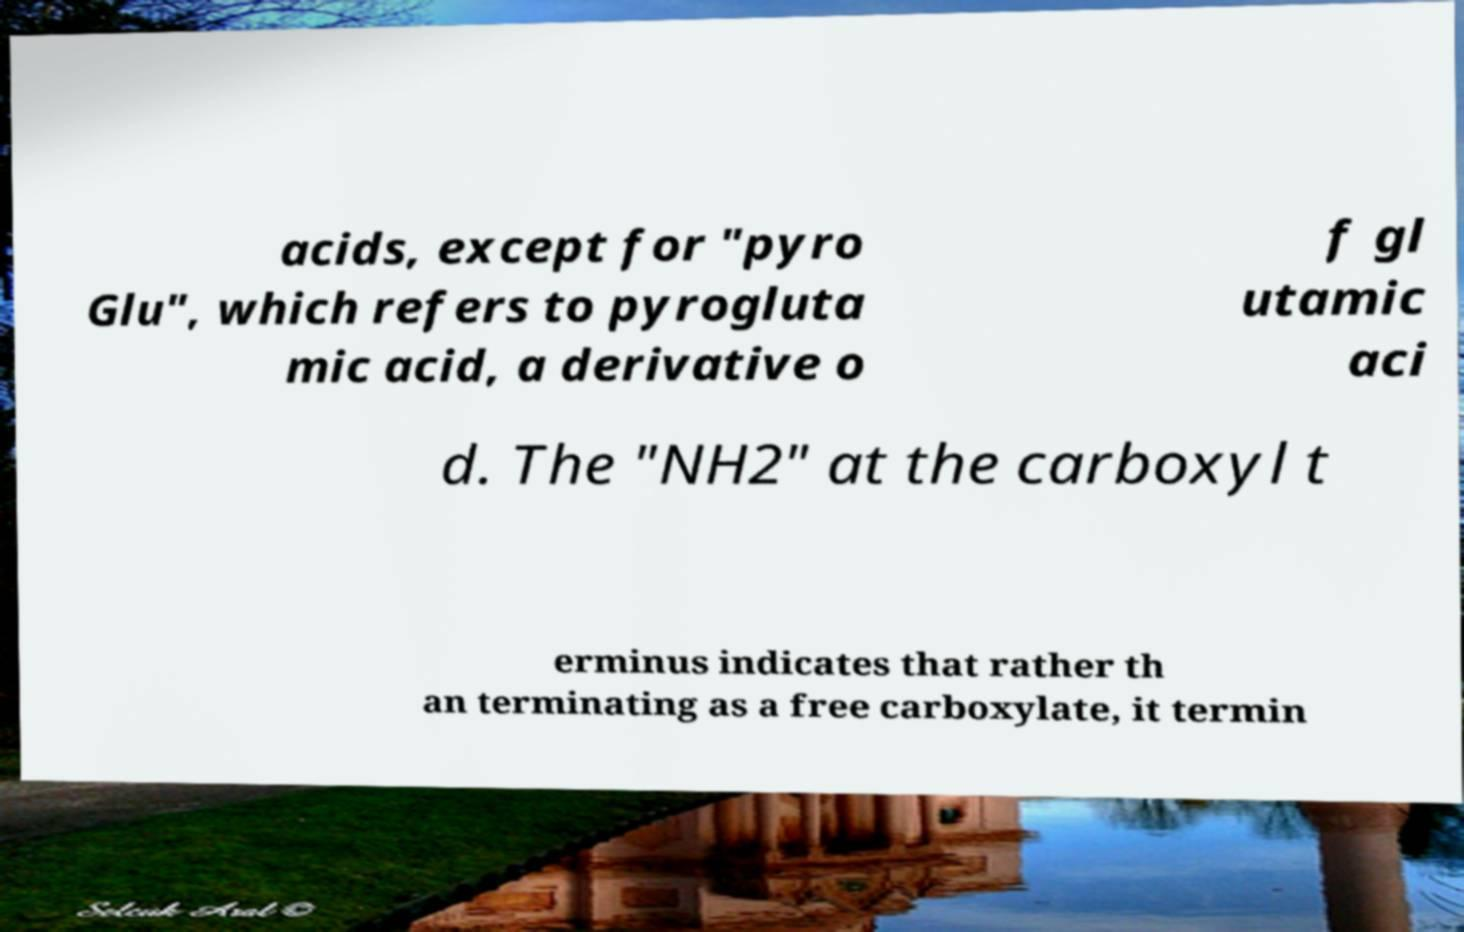Please identify and transcribe the text found in this image. acids, except for "pyro Glu", which refers to pyrogluta mic acid, a derivative o f gl utamic aci d. The "NH2" at the carboxyl t erminus indicates that rather th an terminating as a free carboxylate, it termin 